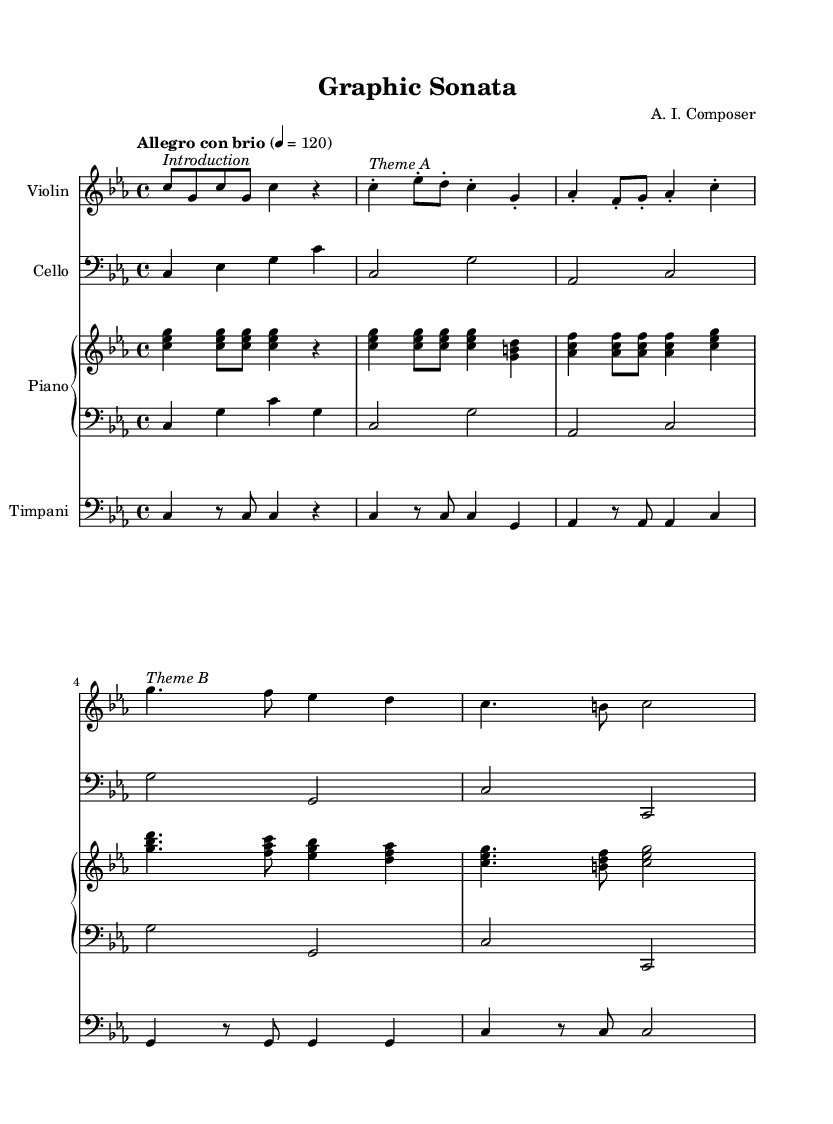What is the key signature of this music? The key signature is indicated at the beginning of the score. It shows C minor, which has three flats: B♭, E♭, and A♭.
Answer: C minor What is the time signature of the piece? The time signature is shown at the beginning of the score, represented by the numbers above the staff. It indicates that there are four beats per measure, which is expressed as 4/4.
Answer: 4/4 What is the tempo marking for this piece? The tempo is specified in the score with a descriptive term and a metronome marking. Here, it says "Allegro con brio," and the metronome marking is set to 120 beats per minute.
Answer: Allegro con brio, 120 How many measures are in the violin part? By counting the vertical bar lines in the violin part, we can determine the number of measures. Each bar line indicates the end of a measure. There are a total of 5 measures in the violin part.
Answer: 5 Which themes are indicated in the violin part? The themes are labeled in the violin part with italicized markings. "Introduction," "Theme A," and "Theme B" are specifically noted at different points in the score.
Answer: Introduction, Theme A, Theme B How does the cello part relate to the violin part? By analyzing the score, the cello part plays a supporting role, providing harmonic support to the violin’s melodic themes. This is commonly seen in classical compositions where cello complements the violin.
Answer: Harmonic support What is the duration of the timpani's final measure? The final measure for the timpani is measured by the note values present. The notation shows a half note followed by a rest, making the total duration of this measure two beats.
Answer: Two beats 